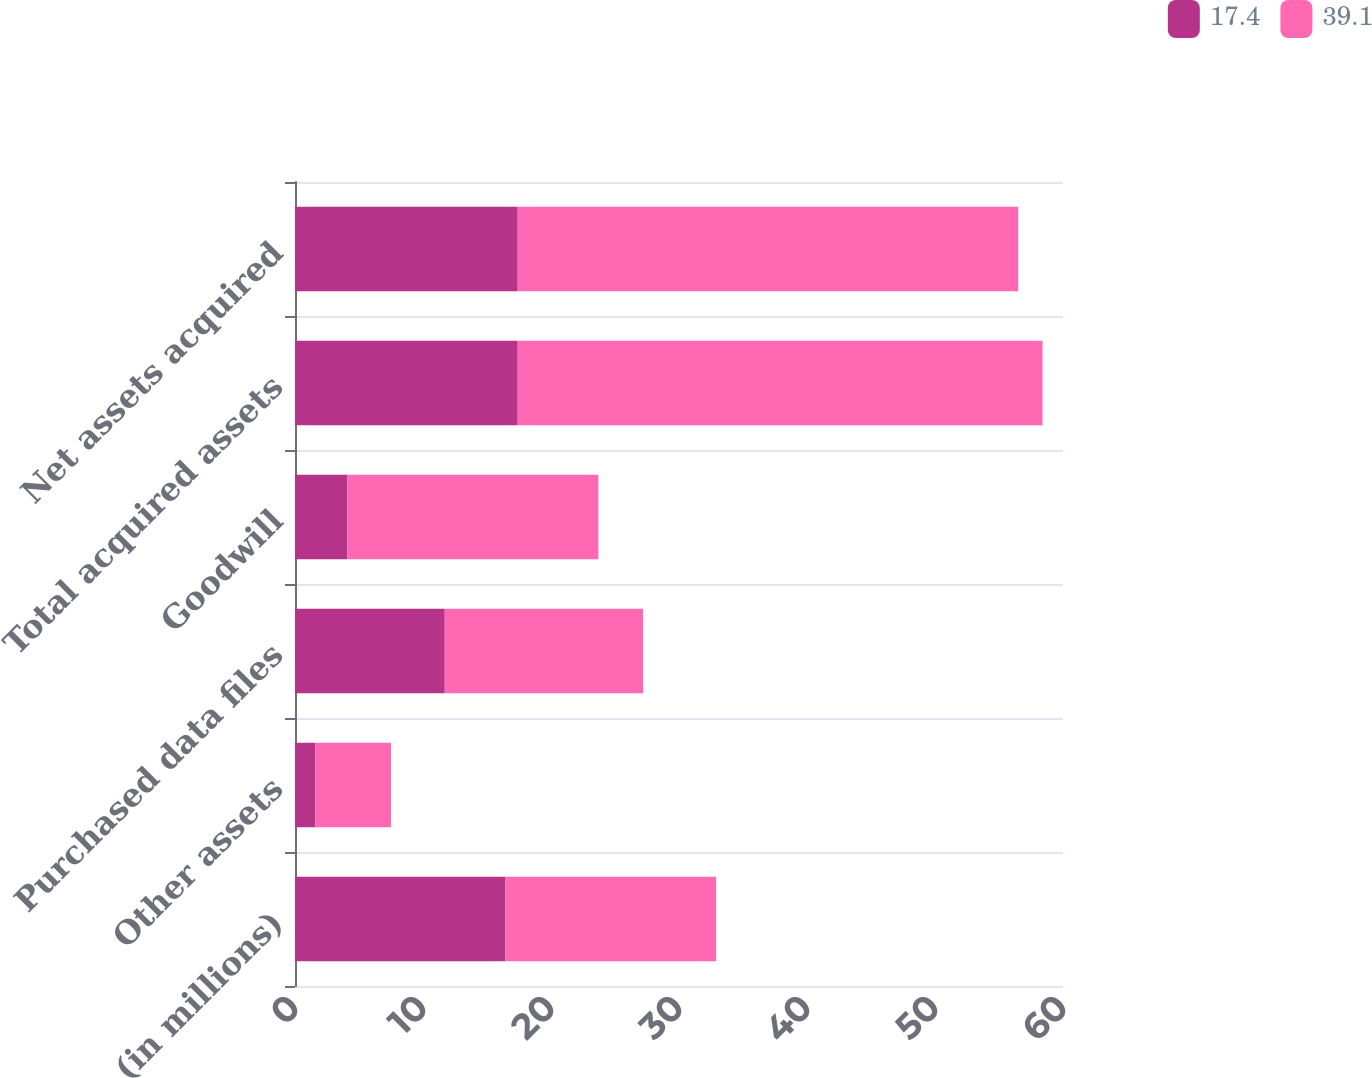Convert chart to OTSL. <chart><loc_0><loc_0><loc_500><loc_500><stacked_bar_chart><ecel><fcel>(in millions)<fcel>Other assets<fcel>Purchased data files<fcel>Goodwill<fcel>Total acquired assets<fcel>Net assets acquired<nl><fcel>17.4<fcel>16.45<fcel>1.6<fcel>11.7<fcel>4.1<fcel>17.4<fcel>17.4<nl><fcel>39.1<fcel>16.45<fcel>5.9<fcel>15.5<fcel>19.6<fcel>41<fcel>39.1<nl></chart> 